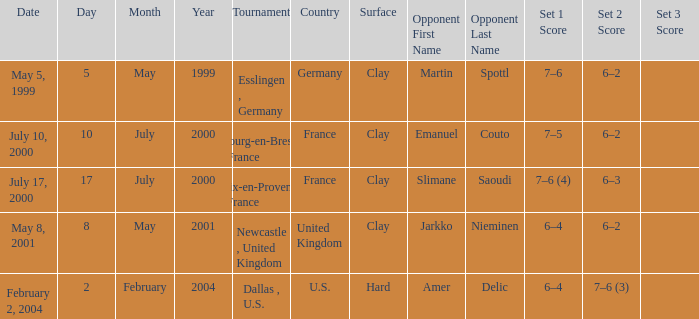What is the Date of the game with a Score of 6–4, 6–2? May 8, 2001. 